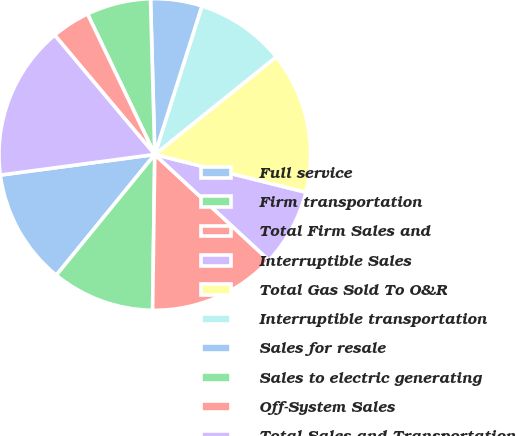Convert chart to OTSL. <chart><loc_0><loc_0><loc_500><loc_500><pie_chart><fcel>Full service<fcel>Firm transportation<fcel>Total Firm Sales and<fcel>Interruptible Sales<fcel>Total Gas Sold To O&R<fcel>Interruptible transportation<fcel>Sales for resale<fcel>Sales to electric generating<fcel>Off-System Sales<fcel>Total Sales and Transportation<nl><fcel>12.0%<fcel>10.67%<fcel>13.33%<fcel>8.0%<fcel>14.67%<fcel>9.33%<fcel>5.33%<fcel>6.67%<fcel>4.0%<fcel>16.0%<nl></chart> 